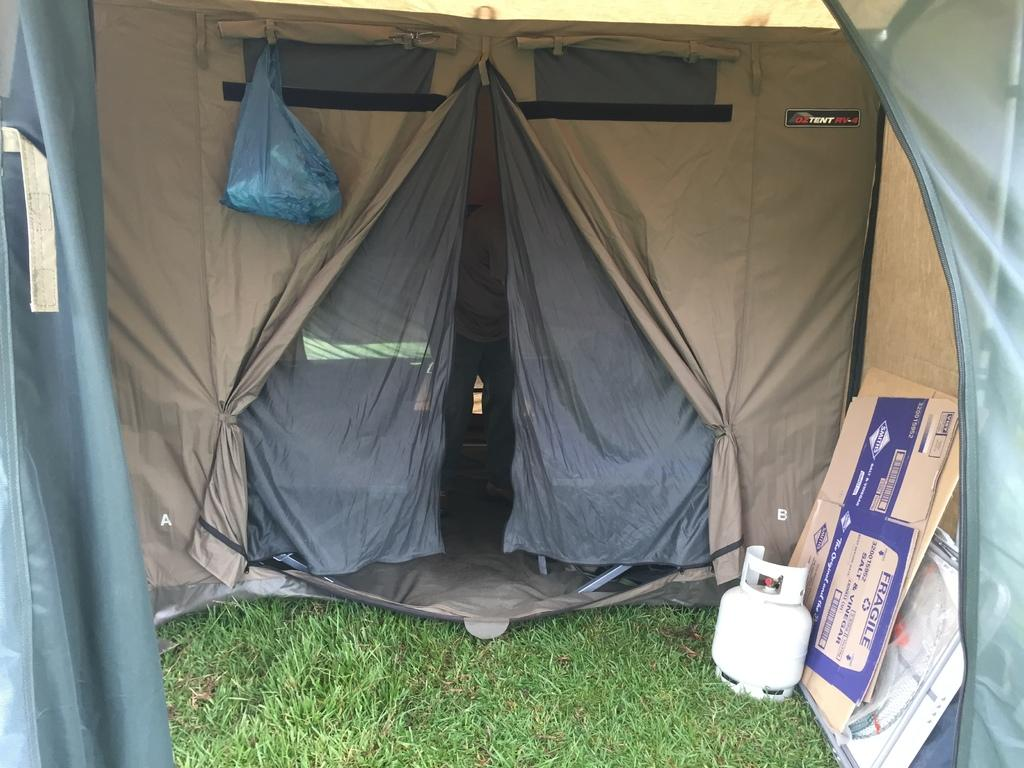What type of shelter is visible in the image? There is a tent in the image. What colors are used for the tent? The tent is in brown and grey colors. What other objects can be seen in the image besides the tent? There are objects in the image, including cardboard sheets. What type of vegetation is present in the image? There is green grass in the image. How does the mist affect the visibility of the tent in the image? There is no mist present in the image, so it does not affect the visibility of the tent. 